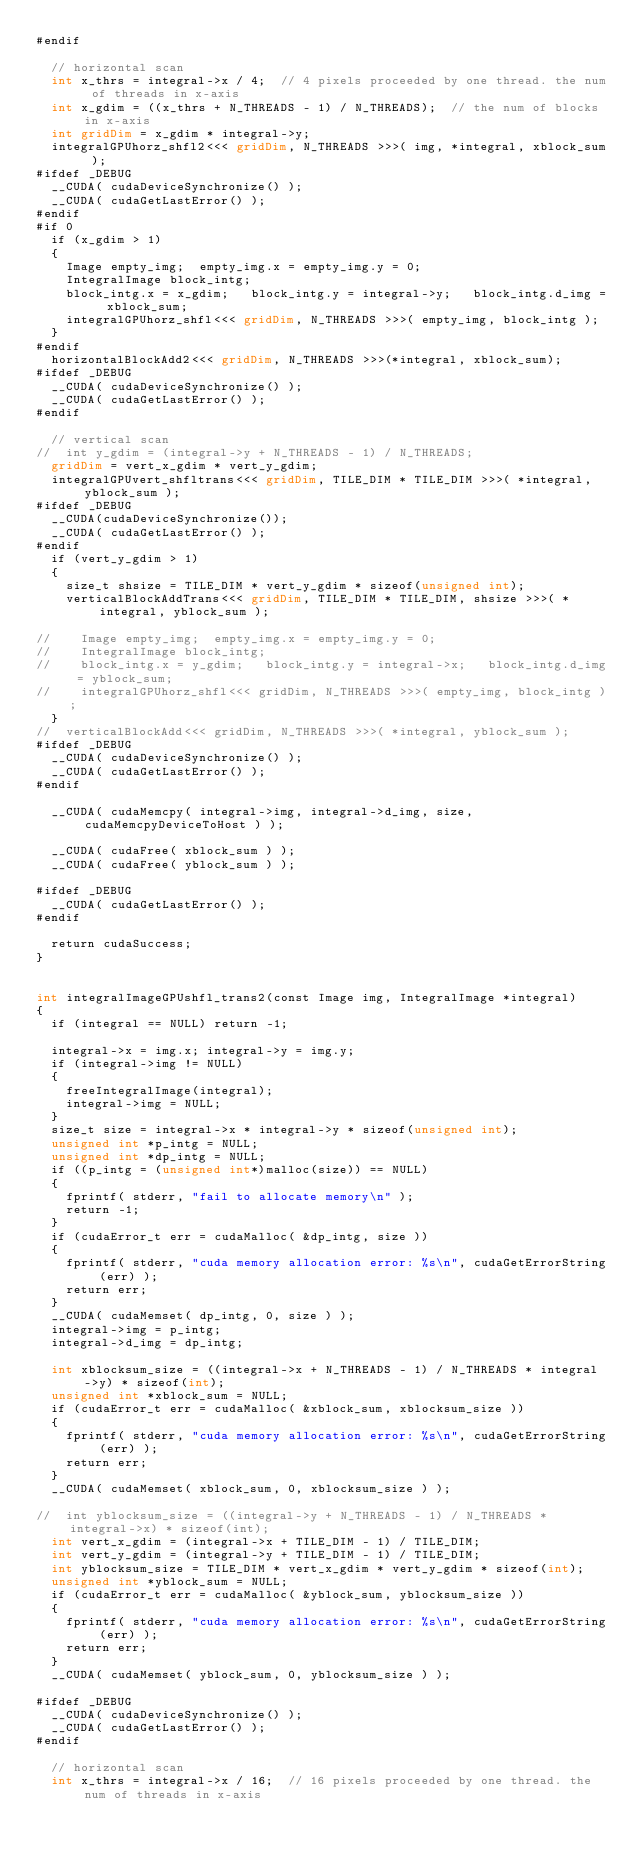<code> <loc_0><loc_0><loc_500><loc_500><_Cuda_>#endif

	// horizontal scan
	int x_thrs = integral->x / 4;  // 4 pixels proceeded by one thread. the num of threads in x-axis
	int x_gdim = ((x_thrs + N_THREADS - 1) / N_THREADS);  // the num of blocks in x-axis
	int gridDim = x_gdim * integral->y;
	integralGPUhorz_shfl2<<< gridDim, N_THREADS >>>( img, *integral, xblock_sum );
#ifdef _DEBUG	
	__CUDA( cudaDeviceSynchronize() );
	__CUDA( cudaGetLastError() );
#endif
#if 0
	if (x_gdim > 1)
	{
		Image empty_img;  empty_img.x = empty_img.y = 0;
		IntegralImage block_intg;
		block_intg.x = x_gdim;   block_intg.y = integral->y;   block_intg.d_img = xblock_sum;
		integralGPUhorz_shfl<<< gridDim, N_THREADS >>>( empty_img, block_intg );
	}
#endif
	horizontalBlockAdd2<<< gridDim, N_THREADS >>>(*integral, xblock_sum);
#ifdef _DEBUG	
	__CUDA( cudaDeviceSynchronize() );
	__CUDA( cudaGetLastError() );
#endif

	// vertical scan
//	int y_gdim = (integral->y + N_THREADS - 1) / N_THREADS;
	gridDim = vert_x_gdim * vert_y_gdim;
	integralGPUvert_shfltrans<<< gridDim, TILE_DIM * TILE_DIM >>>( *integral, yblock_sum );
#ifdef _DEBUG	
	__CUDA(cudaDeviceSynchronize());
	__CUDA( cudaGetLastError() );
#endif
	if (vert_y_gdim > 1)
	{
		size_t shsize = TILE_DIM * vert_y_gdim * sizeof(unsigned int);
		verticalBlockAddTrans<<< gridDim, TILE_DIM * TILE_DIM, shsize >>>( *integral, yblock_sum );

//		Image empty_img;  empty_img.x = empty_img.y = 0;
//		IntegralImage block_intg;
//		block_intg.x = y_gdim;   block_intg.y = integral->x;   block_intg.d_img = yblock_sum;
//		integralGPUhorz_shfl<<< gridDim, N_THREADS >>>( empty_img, block_intg );
	}
//	verticalBlockAdd<<< gridDim, N_THREADS >>>( *integral, yblock_sum );
#ifdef _DEBUG	
	__CUDA( cudaDeviceSynchronize() );
	__CUDA( cudaGetLastError() );
#endif

	__CUDA( cudaMemcpy( integral->img, integral->d_img, size, cudaMemcpyDeviceToHost ) );

	__CUDA( cudaFree( xblock_sum ) );
	__CUDA( cudaFree( yblock_sum ) );

#ifdef _DEBUG	
	__CUDA( cudaGetLastError() );
#endif

	return cudaSuccess;
}


int integralImageGPUshfl_trans2(const Image img, IntegralImage *integral)
{
	if (integral == NULL) return -1;

	integral->x = img.x; integral->y = img.y;
	if (integral->img != NULL)
	{
		freeIntegralImage(integral);
		integral->img = NULL;
	}
	size_t size = integral->x * integral->y * sizeof(unsigned int);
	unsigned int *p_intg = NULL;
	unsigned int *dp_intg = NULL;
	if ((p_intg = (unsigned int*)malloc(size)) == NULL)
	{
		fprintf( stderr, "fail to allocate memory\n" );
		return -1;
	}
	if (cudaError_t err = cudaMalloc( &dp_intg, size ))
	{
		fprintf( stderr, "cuda memory allocation error: %s\n", cudaGetErrorString(err) );
		return err;
	}
	__CUDA( cudaMemset( dp_intg, 0, size ) );
	integral->img = p_intg;
	integral->d_img = dp_intg;

	int xblocksum_size = ((integral->x + N_THREADS - 1) / N_THREADS * integral->y) * sizeof(int);
	unsigned int *xblock_sum = NULL;
	if (cudaError_t err = cudaMalloc( &xblock_sum, xblocksum_size ))
	{
		fprintf( stderr, "cuda memory allocation error: %s\n", cudaGetErrorString(err) );
		return err;
	}
	__CUDA( cudaMemset( xblock_sum, 0, xblocksum_size ) );

//	int yblocksum_size = ((integral->y + N_THREADS - 1) / N_THREADS * integral->x) * sizeof(int);
	int vert_x_gdim = (integral->x + TILE_DIM - 1) / TILE_DIM;
	int vert_y_gdim = (integral->y + TILE_DIM - 1) / TILE_DIM;
	int yblocksum_size = TILE_DIM * vert_x_gdim * vert_y_gdim * sizeof(int);
	unsigned int *yblock_sum = NULL;
	if (cudaError_t err = cudaMalloc( &yblock_sum, yblocksum_size ))
	{
		fprintf( stderr, "cuda memory allocation error: %s\n", cudaGetErrorString(err) );
		return err;
	}
	__CUDA( cudaMemset( yblock_sum, 0, yblocksum_size ) );

#ifdef _DEBUG	
	__CUDA( cudaDeviceSynchronize() );
	__CUDA( cudaGetLastError() );
#endif

	// horizontal scan
	int x_thrs = integral->x / 16;  // 16 pixels proceeded by one thread. the num of threads in x-axis</code> 